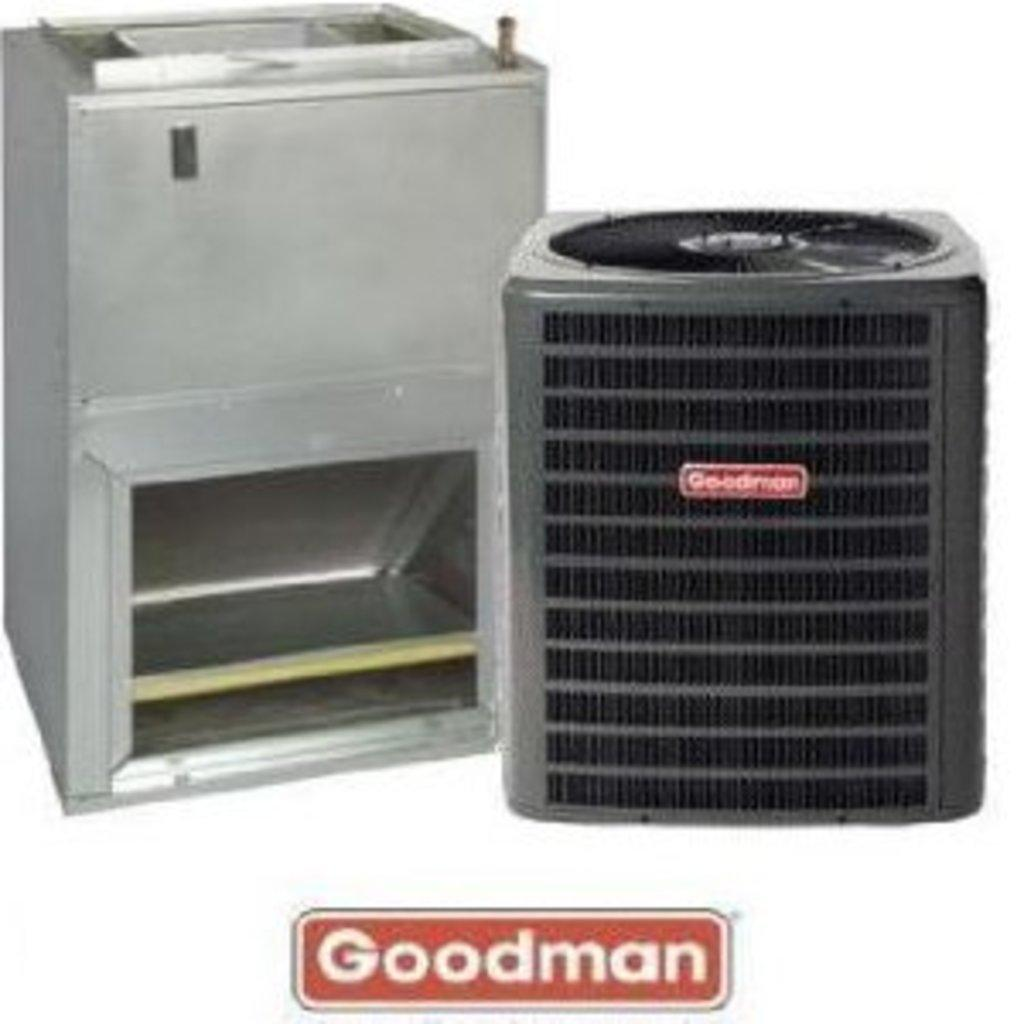<image>
Render a clear and concise summary of the photo. A brand new goodman central air conditioner unit. 